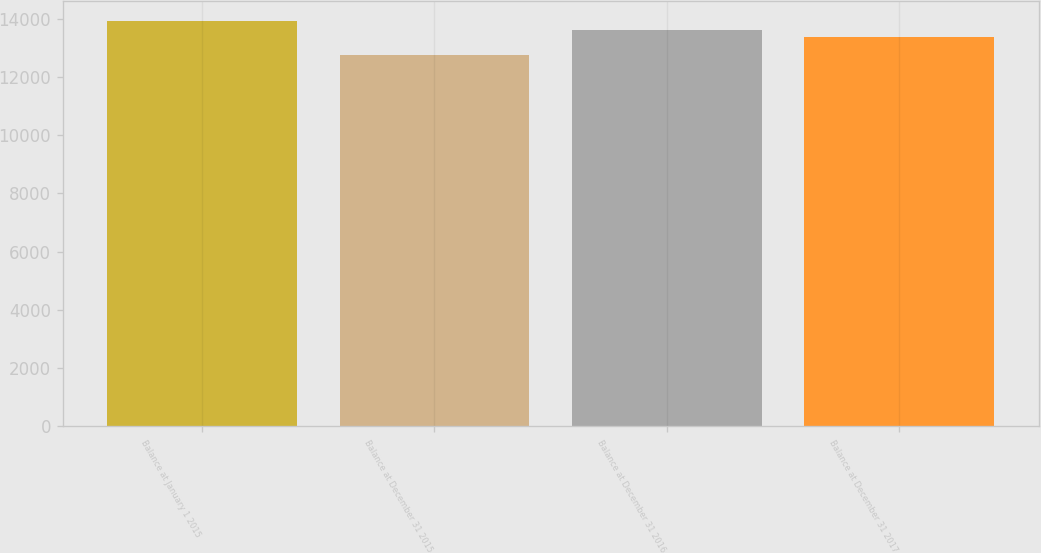Convert chart. <chart><loc_0><loc_0><loc_500><loc_500><bar_chart><fcel>Balance at January 1 2015<fcel>Balance at December 31 2015<fcel>Balance at December 31 2016<fcel>Balance at December 31 2017<nl><fcel>13903<fcel>12748<fcel>13623<fcel>13376<nl></chart> 